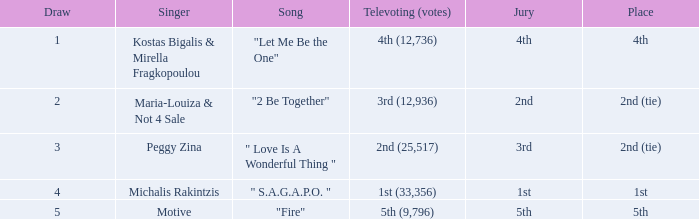What song was 2nd (25,517) in televoting (votes)? " Love Is A Wonderful Thing ". 